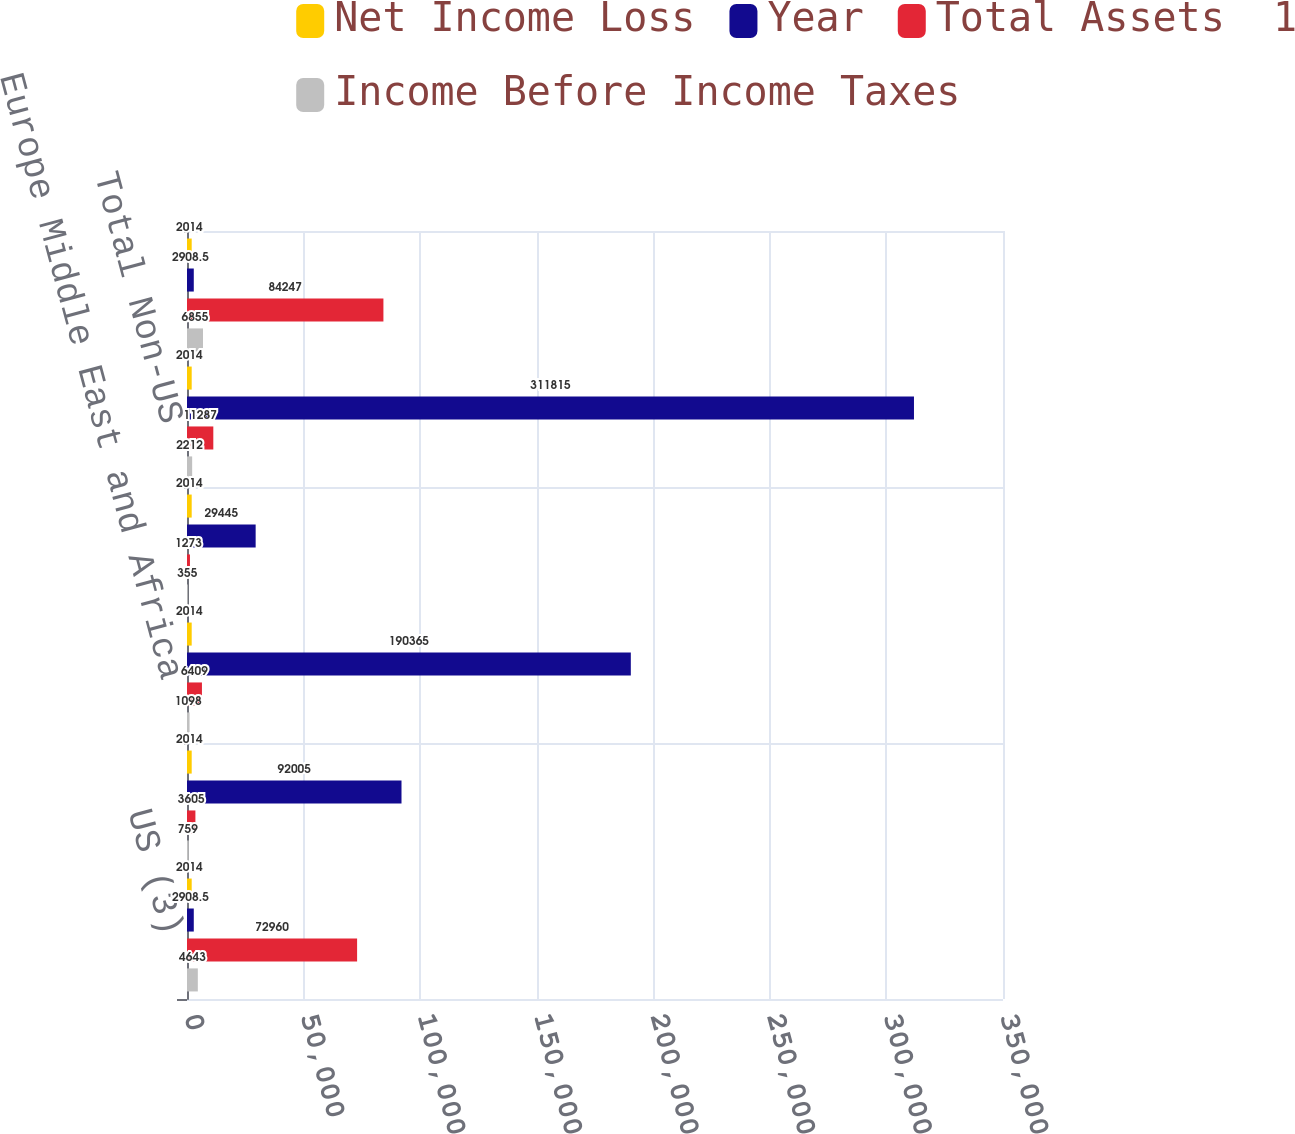Convert chart to OTSL. <chart><loc_0><loc_0><loc_500><loc_500><stacked_bar_chart><ecel><fcel>US (3)<fcel>Asia (4)<fcel>Europe Middle East and Africa<fcel>Latin America and the<fcel>Total Non-US<fcel>Total Consolidated<nl><fcel>Net Income Loss<fcel>2014<fcel>2014<fcel>2014<fcel>2014<fcel>2014<fcel>2014<nl><fcel>Year<fcel>2908.5<fcel>92005<fcel>190365<fcel>29445<fcel>311815<fcel>2908.5<nl><fcel>Total Assets  1<fcel>72960<fcel>3605<fcel>6409<fcel>1273<fcel>11287<fcel>84247<nl><fcel>Income Before Income Taxes<fcel>4643<fcel>759<fcel>1098<fcel>355<fcel>2212<fcel>6855<nl></chart> 